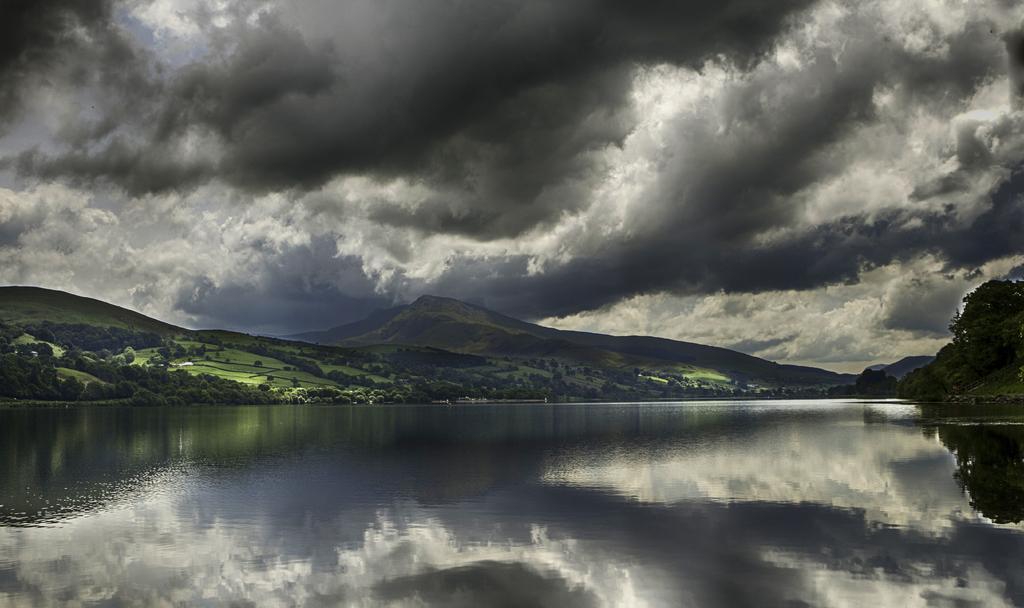Describe this image in one or two sentences. In the picture we can see water and far away from it, we can see hills with a grass surface, plants and some trees on it and behind it we can see the sky with clouds. 